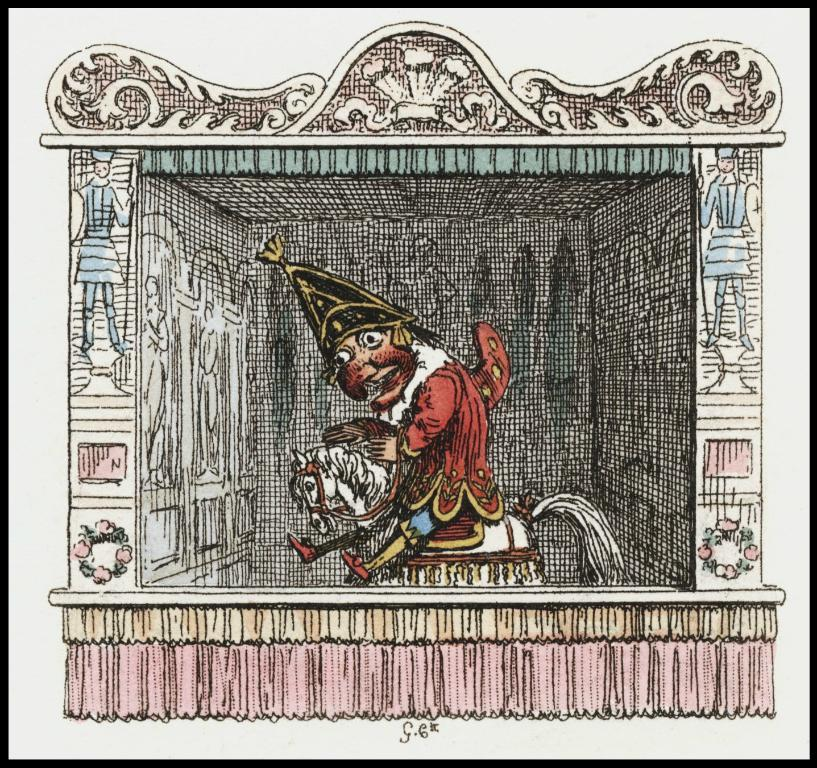What is the main subject of the image? There is an art piece in the image. What does the art piece depict? The art piece depicts a cartoon person sitting on a horse. Are there any other cartoon pictures in the image? Yes, there are other cartoon pictures in the image. What can be observed in terms of design elements in the image? There are designs in the image. What type of decoration is present on the wall in the image? There are flowers on the wall in the image. How many passengers are visible in the image? There are no passengers present in the image; it features an art piece with cartoon characters. What type of canvas is used for the art piece in the image? The image does not provide information about the canvas used for the art piece, as it only shows the final result. 